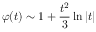<formula> <loc_0><loc_0><loc_500><loc_500>\varphi ( t ) \sim 1 + { \frac { t ^ { 2 } } { 3 } } \ln | t |</formula> 